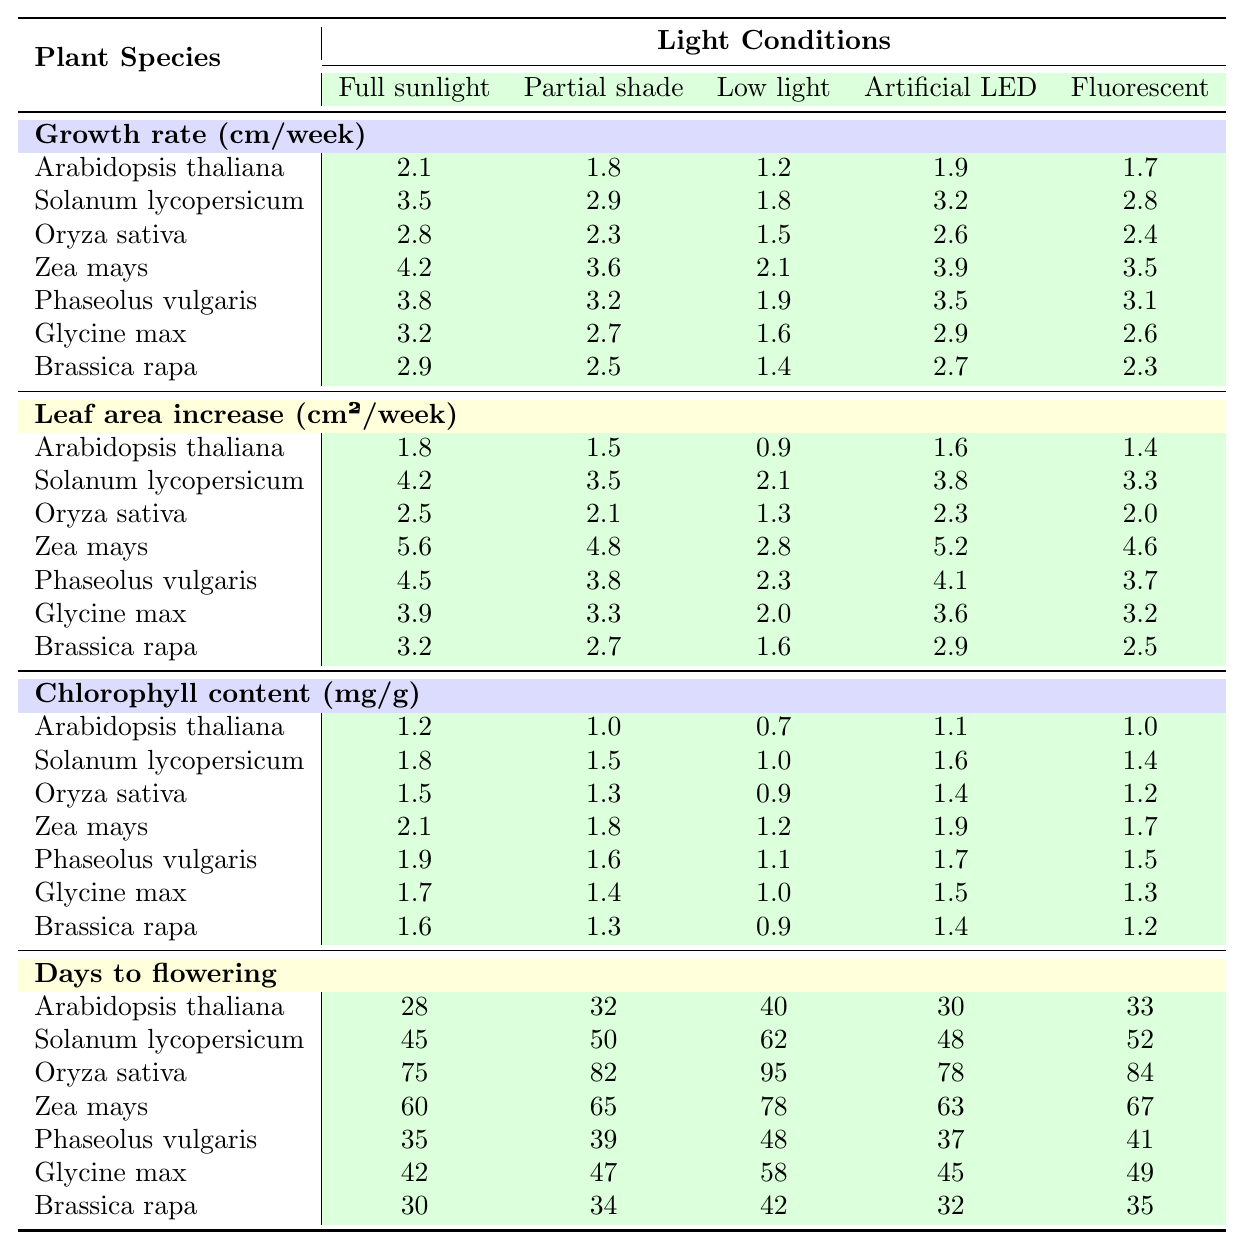What is the growth rate of Zea mays under full sunlight? According to the table, the growth rate of Zea mays under full sunlight is listed as 4.2 cm per week.
Answer: 4.2 cm/week Which plant species shows the highest leaf area increase under partial shade? By looking through the leaf area increase values under partial shade, Solanum lycopersicum has the highest value at 3.5 cm² per week.
Answer: Solanum lycopersicum What is the average chlorophyll content per gram for Glycine max across all light conditions? The chlorophyll content values for Glycine max are 1.7, 1.4, 1.0, 1.5, and 1.3 mg per gram. Summing these gives 1.7 + 1.4 + 1.0 + 1.5 + 1.3 = 7.9 mg. Dividing by 5 (the number of data points) gives an average of 7.9 / 5 = 1.58 mg per gram.
Answer: 1.58 mg/g How does the growth rate of Arabidopsis thaliana in low light compare to that in full sunlight? The growth rate of Arabidopsis thaliana in low light is 1.2 cm per week and in full sunlight is 2.1 cm per week. 2.1 - 1.2 = 0.9 cm per week difference. Therefore, it grows 0.9 cm per week more in full sunlight.
Answer: 0.9 cm/week Is it true that Zea mays reaches flowering earlier than Oryza sativa under any light condition? Examining the days to flowering data, Zea mays takes 60, 65, 78, 63, and 67 days to flower, while Oryza sativa takes 75, 82, 95, 78, and 84 days. Since Zea mays's values are consistently lower than Oryza sativa's, the statement is true.
Answer: Yes What is the difference in days to flowering between the fastest and slowest flowering plants under fluorescent light? The days to flowering for plants under fluorescent light are: Arabidopsis thaliana (33), Solanum lycopersicum (52), Oryza sativa (84), Zea mays (67), Phaseolus vulgaris (41), Glycine max (49), and Brassica rapa (35). The maximum is 84 (Oryza sativa) and the minimum is 33 (Arabidopsis thaliana), so 84 - 33 = 51 days difference.
Answer: 51 days What is the highest recorded chlorophyll content among all species under artificial LED light? By examining the chlorophyll content under artificial LED, the values are 1.1 (Arabidopsis thaliana), 1.6 (Solanum lycopersicum), 1.4 (Oryza sativa), 1.9 (Zea mays), 1.7 (Phaseolus vulgaris), 1.5 (Glycine max), and 1.4 (Brassica rapa). The highest recorded is 1.9 mg per gram for Zea mays.
Answer: 1.9 mg/g Which light condition yields the best growth rate for Phaseolus vulgaris? The growth rates for Phaseolus vulgaris under different light conditions are: 3.8 (full sunlight), 3.2 (partial shade), 1.9 (low light), 3.5 (artificial LED), and 3.1 (fluorescent). The highest is 3.8 cm per week under full sunlight.
Answer: Full sunlight What is the total increase in leaf area for Oryza sativa across all light conditions? The leaf area increase values for Oryza sativa are 2.5, 2.1, 1.3, 2.3, and 2.0 cm². Summing these gives 2.5 + 2.1 + 1.3 + 2.3 + 2.0 = 11.2 cm² total increase.
Answer: 11.2 cm² How does Glycine max perform in terms of growth rate in low light compared to its performance in fluorescent light? Glycine max has a growth rate of 1.6 cm per week in low light and 2.6 cm per week in fluorescent light. The difference is 2.6 - 1.6 = 1.0 cm per week, indicating it grows better in fluorescent light by 1.0 cm/week.
Answer: 1.0 cm/week 